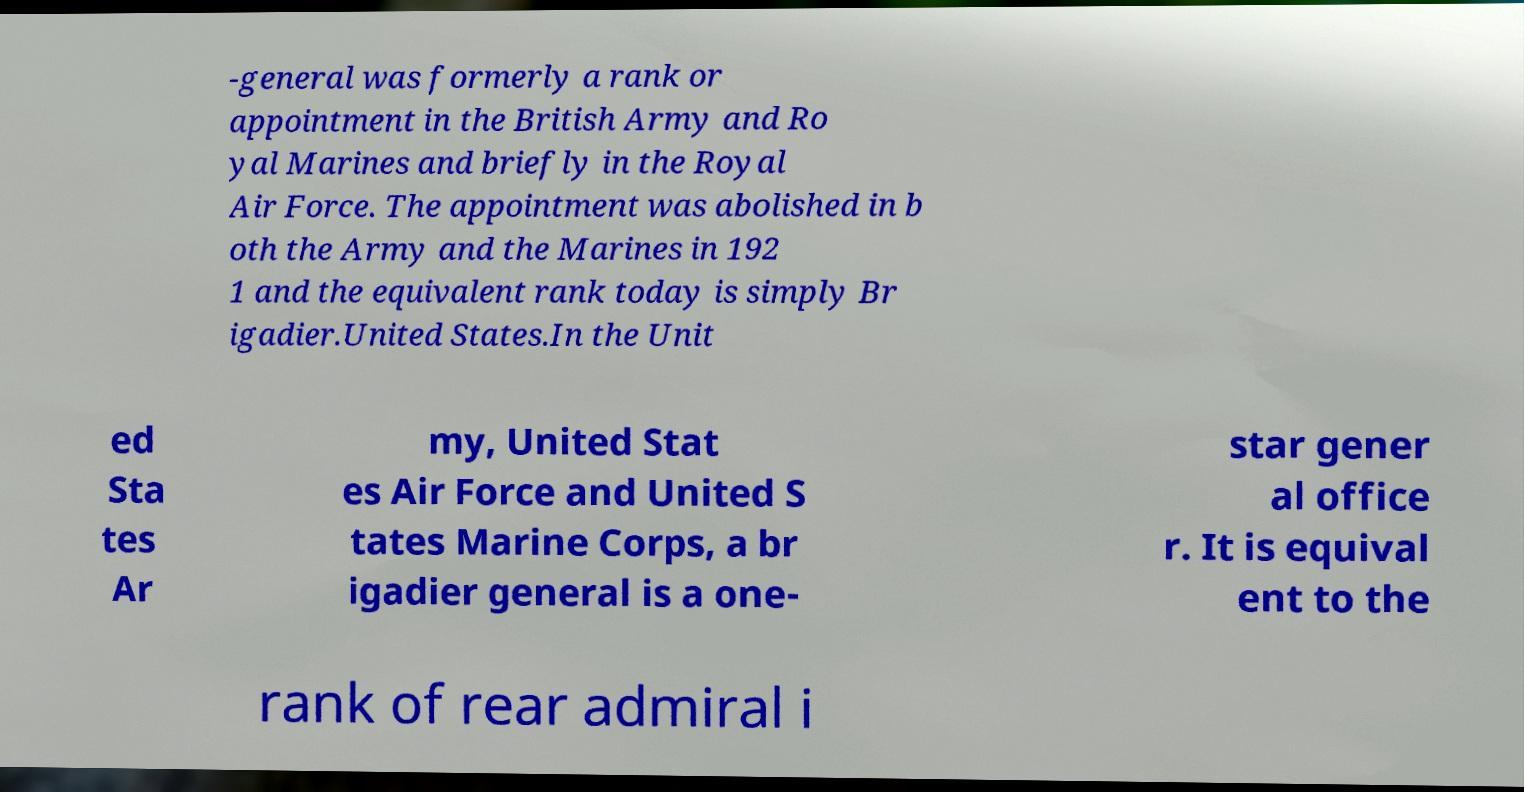Can you read and provide the text displayed in the image?This photo seems to have some interesting text. Can you extract and type it out for me? -general was formerly a rank or appointment in the British Army and Ro yal Marines and briefly in the Royal Air Force. The appointment was abolished in b oth the Army and the Marines in 192 1 and the equivalent rank today is simply Br igadier.United States.In the Unit ed Sta tes Ar my, United Stat es Air Force and United S tates Marine Corps, a br igadier general is a one- star gener al office r. It is equival ent to the rank of rear admiral i 